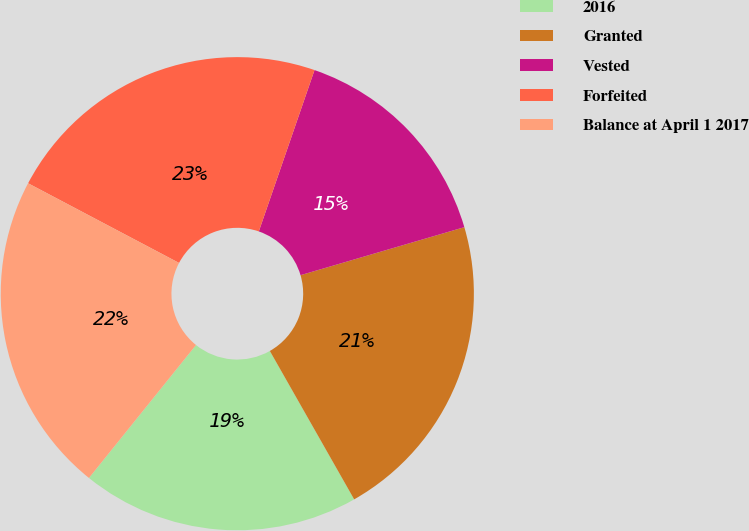Convert chart to OTSL. <chart><loc_0><loc_0><loc_500><loc_500><pie_chart><fcel>2016<fcel>Granted<fcel>Vested<fcel>Forfeited<fcel>Balance at April 1 2017<nl><fcel>19.01%<fcel>21.31%<fcel>15.17%<fcel>22.56%<fcel>21.94%<nl></chart> 